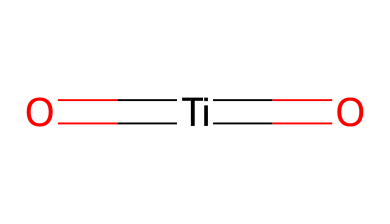What is the central atom in this chemical structure? The structure shows titanium, which is the central metal atom. It is directly bonded to two oxygen atoms.
Answer: titanium How many oxygen atoms are attached to the titanium atom? The structure indicates that there are two oxygen atoms connected to the titanium atom, represented by the two bonds to oxygen in the SMILES notation.
Answer: two What type of bonds are present in this compound? The SMILES shows double bonds between titanium and each oxygen atom, indicating that the compound has two double bonds.
Answer: double Is titanium dioxide an organometallic compound? Organometallic compounds typically contain a metal directly bonded to carbon. Since titanium dioxide does not contain carbon, it is considered an inorganic compound.
Answer: no What is the oxidation state of titanium in this compound? In titanium dioxide, the titanium is generally considered to be in the +4 oxidation state, which balances the -2 charge from the two oxygen atoms (-2 each) in the overall neutral compound.
Answer: +4 What is the overall charge of titanium dioxide? The combination of the +4 charge from titanium and the -4 charge from the two oxygen atoms results in an overall neutral charge of 0 for the compound.
Answer: 0 